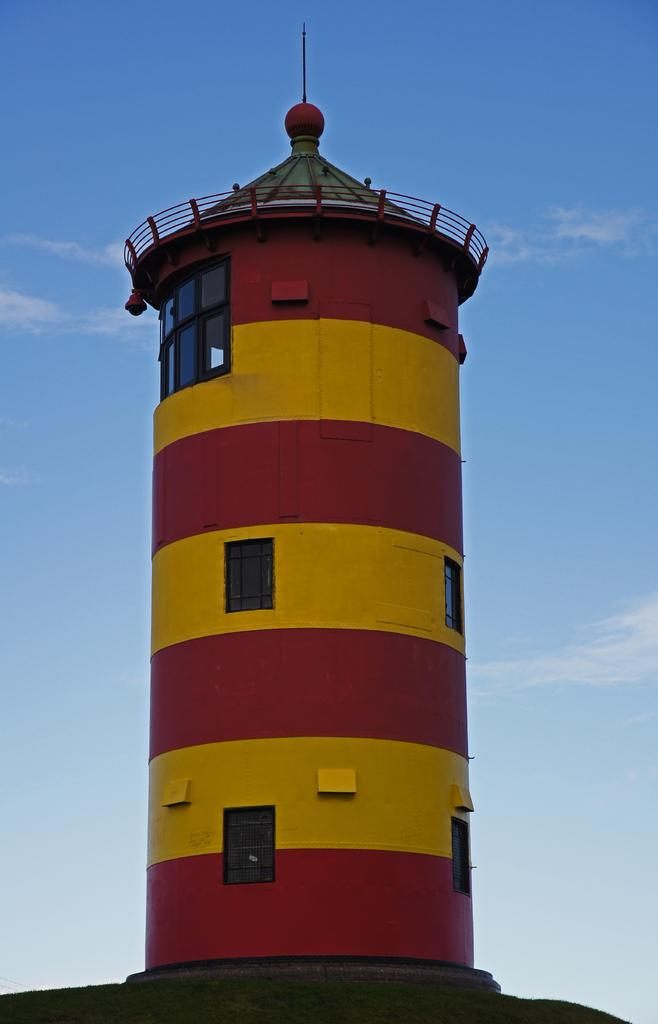What is the main subject of the image? The main subject of the image is a lighthouse. What specific features can be seen on the lighthouse? The lighthouse has windows. What can be seen in the background of the image? The sky is visible in the background of the image. What is the condition of the sky in the image? Clouds are present in the sky. What type of song is being played by the lighthouse in the image? There is no indication in the image that the lighthouse is playing a song, as lighthouses do not have the ability to play music. 